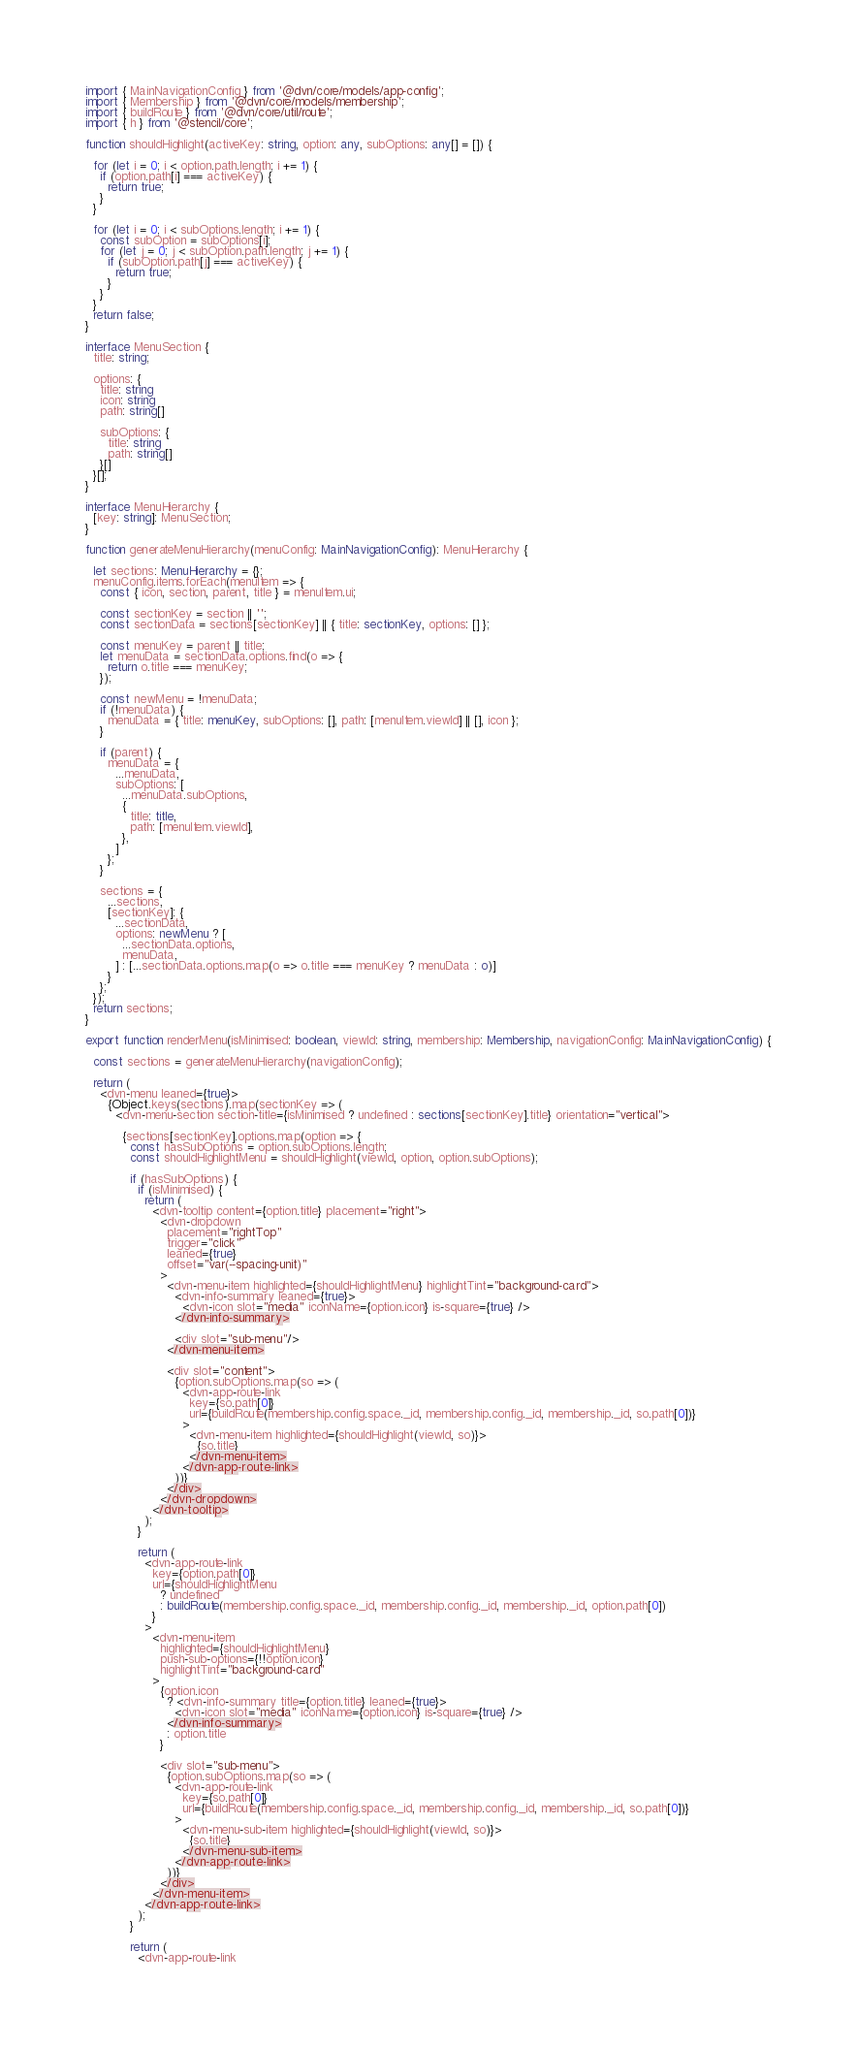<code> <loc_0><loc_0><loc_500><loc_500><_TypeScript_>import { MainNavigationConfig } from '@dvn/core/models/app-config';
import { Membership } from '@dvn/core/models/membership';
import { buildRoute } from '@dvn/core/util/route';
import { h } from '@stencil/core';

function shouldHighlight(activeKey: string, option: any, subOptions: any[] = []) {

  for (let i = 0; i < option.path.length; i += 1) {
    if (option.path[i] === activeKey) {
      return true;
    }
  }

  for (let i = 0; i < subOptions.length; i += 1) {
    const subOption = subOptions[i];
    for (let j = 0; j < subOption.path.length; j += 1) {
      if (subOption.path[j] === activeKey) {
        return true;
      }
    }
  }
  return false;
}

interface MenuSection {
  title: string;

  options: {
    title: string
    icon: string
    path: string[]

    subOptions: {
      title: string
      path: string[]
    }[]
  }[];
}

interface MenuHierarchy {
  [key: string]: MenuSection;
}

function generateMenuHierarchy(menuConfig: MainNavigationConfig): MenuHierarchy {

  let sections: MenuHierarchy = {};
  menuConfig.items.forEach(menuItem => {
    const { icon, section, parent, title } = menuItem.ui;

    const sectionKey = section || '';
    const sectionData = sections[sectionKey] || { title: sectionKey, options: [] };

    const menuKey = parent || title;
    let menuData = sectionData.options.find(o => {
      return o.title === menuKey;
    });

    const newMenu = !menuData;
    if (!menuData) {
      menuData = { title: menuKey, subOptions: [], path: [menuItem.viewId] || [], icon };
    }

    if (parent) {
      menuData = {
        ...menuData,
        subOptions: [
          ...menuData.subOptions,
          {
            title: title,
            path: [menuItem.viewId],
          },
        ]
      };
    }

    sections = {
      ...sections,
      [sectionKey]: {
        ...sectionData,
        options: newMenu ? [
          ...sectionData.options,
          menuData,
        ] : [...sectionData.options.map(o => o.title === menuKey ? menuData : o)]
      }
    };
  });
  return sections;
}

export function renderMenu(isMinimised: boolean, viewId: string, membership: Membership, navigationConfig: MainNavigationConfig) {

  const sections = generateMenuHierarchy(navigationConfig);

  return (
    <dvn-menu leaned={true}>
      {Object.keys(sections).map(sectionKey => (
        <dvn-menu-section section-title={isMinimised ? undefined : sections[sectionKey].title} orientation="vertical">

          {sections[sectionKey].options.map(option => {
            const hasSubOptions = option.subOptions.length;
            const shouldHighlightMenu = shouldHighlight(viewId, option, option.subOptions);

            if (hasSubOptions) {
              if (isMinimised) {
                return (
                  <dvn-tooltip content={option.title} placement="right">
                    <dvn-dropdown
                      placement="rightTop"
                      trigger="click"
                      leaned={true}
                      offset="var(--spacing-unit)"
                    >
                      <dvn-menu-item highlighted={shouldHighlightMenu} highlightTint="background-card">
                        <dvn-info-summary leaned={true}>
                          <dvn-icon slot="media" iconName={option.icon} is-square={true} />
                        </dvn-info-summary>

                        <div slot="sub-menu"/>
                      </dvn-menu-item>

                      <div slot="content">
                        {option.subOptions.map(so => (
                          <dvn-app-route-link
                            key={so.path[0]}
                            url={buildRoute(membership.config.space._id, membership.config._id, membership._id, so.path[0])}
                          >
                            <dvn-menu-item highlighted={shouldHighlight(viewId, so)}>
                              {so.title}
                            </dvn-menu-item>
                          </dvn-app-route-link>
                        ))}
                      </div>
                    </dvn-dropdown>
                  </dvn-tooltip>
                );
              }

              return (
                <dvn-app-route-link
                  key={option.path[0]}
                  url={shouldHighlightMenu
                    ? undefined
                    : buildRoute(membership.config.space._id, membership.config._id, membership._id, option.path[0])
                  }
                >
                  <dvn-menu-item
                    highlighted={shouldHighlightMenu}
                    push-sub-options={!!option.icon}
                    highlightTint="background-card"
                  >
                    {option.icon
                      ? <dvn-info-summary title={option.title} leaned={true}>
                        <dvn-icon slot="media" iconName={option.icon} is-square={true} />
                      </dvn-info-summary>
                      : option.title
                    }

                    <div slot="sub-menu">
                      {option.subOptions.map(so => (
                        <dvn-app-route-link
                          key={so.path[0]}
                          url={buildRoute(membership.config.space._id, membership.config._id, membership._id, so.path[0])}
                        >
                          <dvn-menu-sub-item highlighted={shouldHighlight(viewId, so)}>
                            {so.title}
                          </dvn-menu-sub-item>
                        </dvn-app-route-link>
                      ))}
                    </div>
                  </dvn-menu-item>
                </dvn-app-route-link>
              );
            }

            return (
              <dvn-app-route-link</code> 